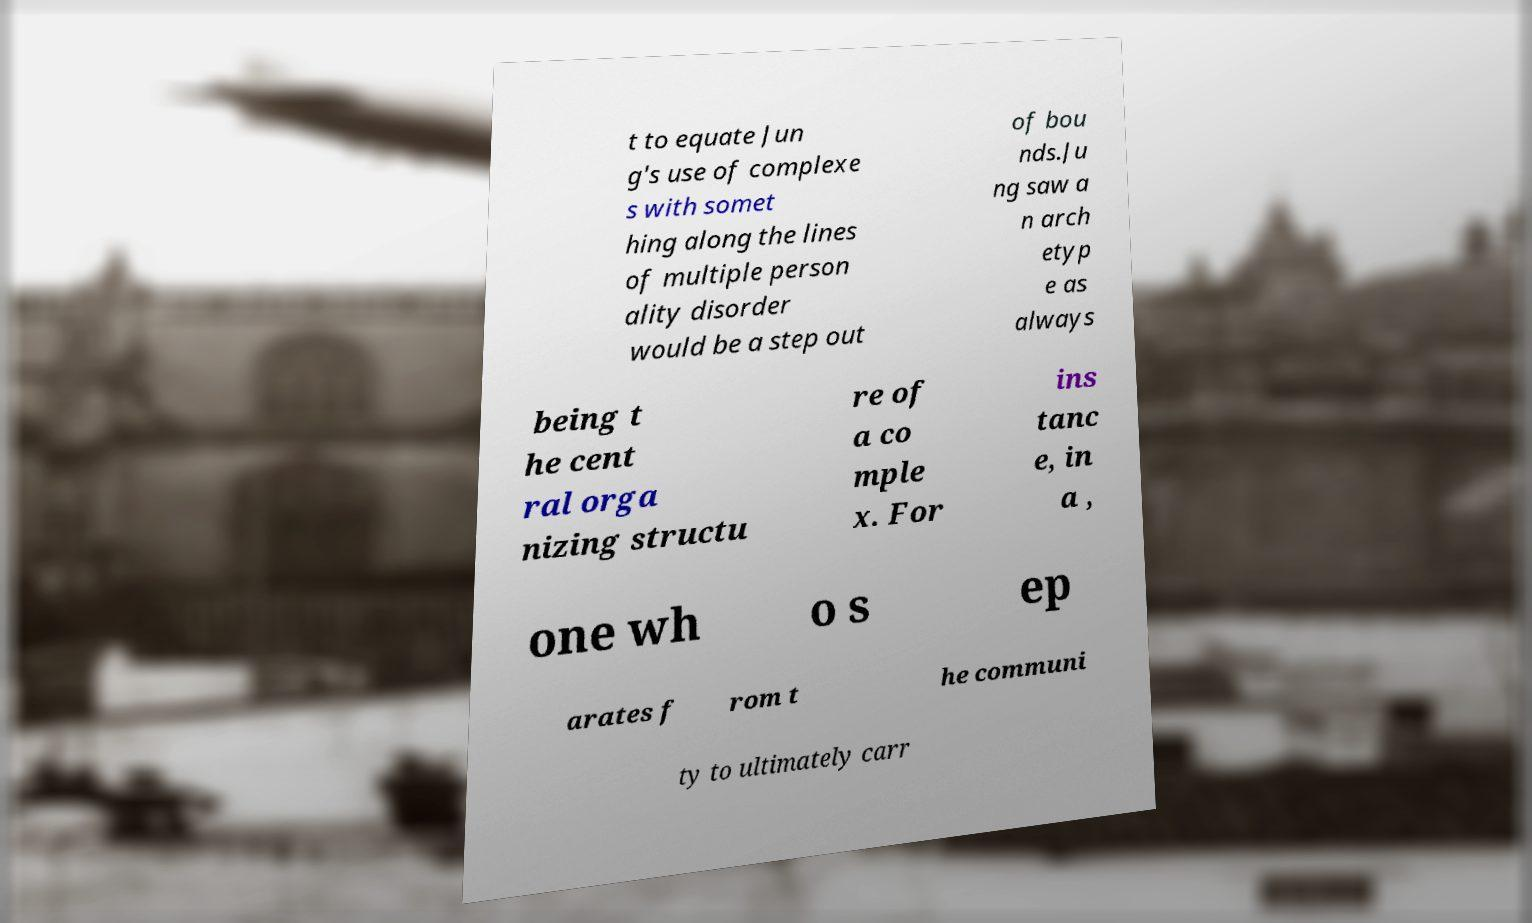Can you accurately transcribe the text from the provided image for me? t to equate Jun g's use of complexe s with somet hing along the lines of multiple person ality disorder would be a step out of bou nds.Ju ng saw a n arch etyp e as always being t he cent ral orga nizing structu re of a co mple x. For ins tanc e, in a , one wh o s ep arates f rom t he communi ty to ultimately carr 